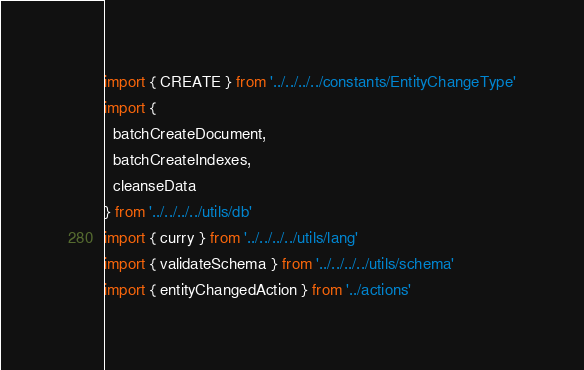<code> <loc_0><loc_0><loc_500><loc_500><_JavaScript_>import { CREATE } from '../../../../constants/EntityChangeType'
import {
  batchCreateDocument,
  batchCreateIndexes,
  cleanseData
} from '../../../../utils/db'
import { curry } from '../../../../utils/lang'
import { validateSchema } from '../../../../utils/schema'
import { entityChangedAction } from '../actions'
</code> 